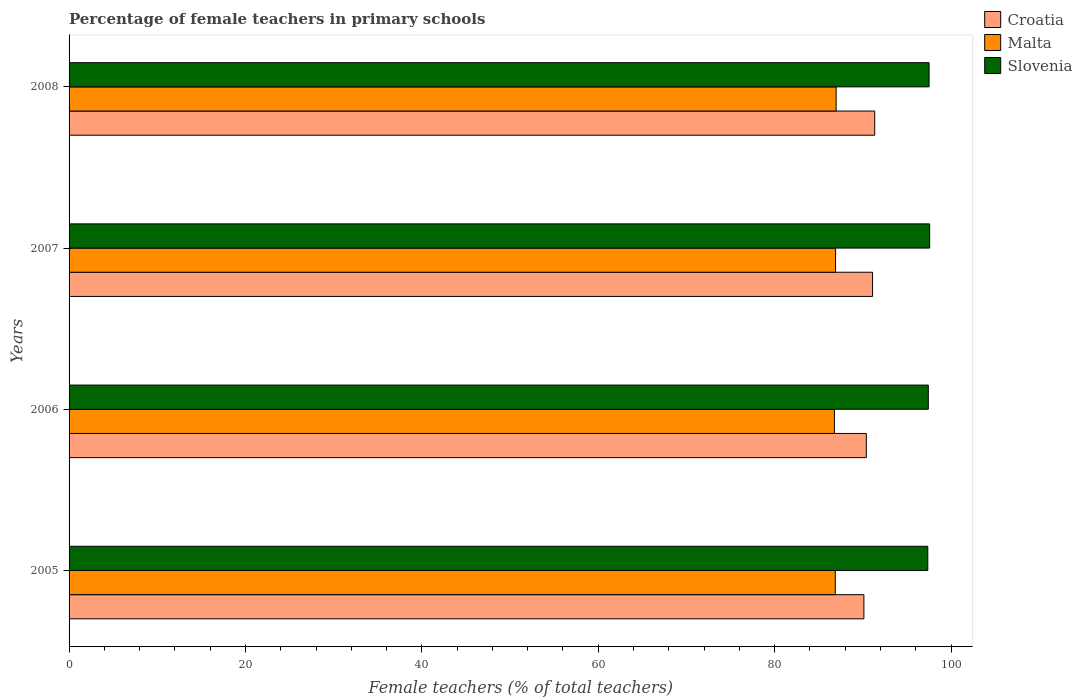How many groups of bars are there?
Keep it short and to the point. 4. Are the number of bars per tick equal to the number of legend labels?
Provide a short and direct response. Yes. In how many cases, is the number of bars for a given year not equal to the number of legend labels?
Make the answer very short. 0. What is the percentage of female teachers in Slovenia in 2008?
Ensure brevity in your answer.  97.51. Across all years, what is the maximum percentage of female teachers in Malta?
Provide a short and direct response. 86.98. Across all years, what is the minimum percentage of female teachers in Slovenia?
Your response must be concise. 97.37. In which year was the percentage of female teachers in Malta minimum?
Your answer should be very brief. 2006. What is the total percentage of female teachers in Slovenia in the graph?
Keep it short and to the point. 389.89. What is the difference between the percentage of female teachers in Malta in 2006 and that in 2007?
Provide a short and direct response. -0.13. What is the difference between the percentage of female teachers in Malta in 2005 and the percentage of female teachers in Slovenia in 2008?
Offer a terse response. -10.63. What is the average percentage of female teachers in Slovenia per year?
Provide a short and direct response. 97.47. In the year 2006, what is the difference between the percentage of female teachers in Slovenia and percentage of female teachers in Malta?
Make the answer very short. 10.65. What is the ratio of the percentage of female teachers in Slovenia in 2005 to that in 2006?
Ensure brevity in your answer.  1. Is the percentage of female teachers in Croatia in 2006 less than that in 2007?
Provide a succinct answer. Yes. What is the difference between the highest and the second highest percentage of female teachers in Croatia?
Your answer should be compact. 0.24. What is the difference between the highest and the lowest percentage of female teachers in Slovenia?
Your response must be concise. 0.21. What does the 3rd bar from the top in 2005 represents?
Provide a short and direct response. Croatia. What does the 2nd bar from the bottom in 2006 represents?
Offer a terse response. Malta. How many bars are there?
Ensure brevity in your answer.  12. Are all the bars in the graph horizontal?
Give a very brief answer. Yes. How many years are there in the graph?
Make the answer very short. 4. What is the difference between two consecutive major ticks on the X-axis?
Your answer should be very brief. 20. Are the values on the major ticks of X-axis written in scientific E-notation?
Your answer should be compact. No. Does the graph contain any zero values?
Your answer should be compact. No. Where does the legend appear in the graph?
Give a very brief answer. Top right. What is the title of the graph?
Your answer should be compact. Percentage of female teachers in primary schools. Does "Greece" appear as one of the legend labels in the graph?
Provide a succinct answer. No. What is the label or title of the X-axis?
Your answer should be very brief. Female teachers (% of total teachers). What is the label or title of the Y-axis?
Your response must be concise. Years. What is the Female teachers (% of total teachers) in Croatia in 2005?
Give a very brief answer. 90.12. What is the Female teachers (% of total teachers) in Malta in 2005?
Your response must be concise. 86.88. What is the Female teachers (% of total teachers) of Slovenia in 2005?
Your response must be concise. 97.37. What is the Female teachers (% of total teachers) of Croatia in 2006?
Ensure brevity in your answer.  90.4. What is the Female teachers (% of total teachers) of Malta in 2006?
Your answer should be compact. 86.78. What is the Female teachers (% of total teachers) of Slovenia in 2006?
Provide a short and direct response. 97.43. What is the Female teachers (% of total teachers) of Croatia in 2007?
Ensure brevity in your answer.  91.11. What is the Female teachers (% of total teachers) in Malta in 2007?
Your answer should be very brief. 86.91. What is the Female teachers (% of total teachers) of Slovenia in 2007?
Your answer should be very brief. 97.58. What is the Female teachers (% of total teachers) of Croatia in 2008?
Offer a terse response. 91.35. What is the Female teachers (% of total teachers) of Malta in 2008?
Give a very brief answer. 86.98. What is the Female teachers (% of total teachers) in Slovenia in 2008?
Give a very brief answer. 97.51. Across all years, what is the maximum Female teachers (% of total teachers) of Croatia?
Provide a succinct answer. 91.35. Across all years, what is the maximum Female teachers (% of total teachers) of Malta?
Your answer should be compact. 86.98. Across all years, what is the maximum Female teachers (% of total teachers) in Slovenia?
Give a very brief answer. 97.58. Across all years, what is the minimum Female teachers (% of total teachers) in Croatia?
Offer a very short reply. 90.12. Across all years, what is the minimum Female teachers (% of total teachers) of Malta?
Give a very brief answer. 86.78. Across all years, what is the minimum Female teachers (% of total teachers) of Slovenia?
Your answer should be compact. 97.37. What is the total Female teachers (% of total teachers) in Croatia in the graph?
Your answer should be very brief. 362.98. What is the total Female teachers (% of total teachers) of Malta in the graph?
Provide a short and direct response. 347.54. What is the total Female teachers (% of total teachers) of Slovenia in the graph?
Provide a short and direct response. 389.89. What is the difference between the Female teachers (% of total teachers) in Croatia in 2005 and that in 2006?
Your answer should be very brief. -0.28. What is the difference between the Female teachers (% of total teachers) in Malta in 2005 and that in 2006?
Offer a very short reply. 0.1. What is the difference between the Female teachers (% of total teachers) in Slovenia in 2005 and that in 2006?
Offer a very short reply. -0.06. What is the difference between the Female teachers (% of total teachers) of Croatia in 2005 and that in 2007?
Give a very brief answer. -0.98. What is the difference between the Female teachers (% of total teachers) in Malta in 2005 and that in 2007?
Offer a terse response. -0.03. What is the difference between the Female teachers (% of total teachers) in Slovenia in 2005 and that in 2007?
Your response must be concise. -0.21. What is the difference between the Female teachers (% of total teachers) in Croatia in 2005 and that in 2008?
Keep it short and to the point. -1.22. What is the difference between the Female teachers (% of total teachers) in Malta in 2005 and that in 2008?
Provide a short and direct response. -0.1. What is the difference between the Female teachers (% of total teachers) in Slovenia in 2005 and that in 2008?
Ensure brevity in your answer.  -0.14. What is the difference between the Female teachers (% of total teachers) of Croatia in 2006 and that in 2007?
Your answer should be very brief. -0.71. What is the difference between the Female teachers (% of total teachers) of Malta in 2006 and that in 2007?
Your response must be concise. -0.13. What is the difference between the Female teachers (% of total teachers) in Slovenia in 2006 and that in 2007?
Your response must be concise. -0.15. What is the difference between the Female teachers (% of total teachers) of Croatia in 2006 and that in 2008?
Provide a succinct answer. -0.95. What is the difference between the Female teachers (% of total teachers) in Malta in 2006 and that in 2008?
Keep it short and to the point. -0.2. What is the difference between the Female teachers (% of total teachers) in Slovenia in 2006 and that in 2008?
Keep it short and to the point. -0.09. What is the difference between the Female teachers (% of total teachers) of Croatia in 2007 and that in 2008?
Make the answer very short. -0.24. What is the difference between the Female teachers (% of total teachers) in Malta in 2007 and that in 2008?
Your response must be concise. -0.07. What is the difference between the Female teachers (% of total teachers) in Slovenia in 2007 and that in 2008?
Provide a succinct answer. 0.07. What is the difference between the Female teachers (% of total teachers) of Croatia in 2005 and the Female teachers (% of total teachers) of Malta in 2006?
Offer a terse response. 3.34. What is the difference between the Female teachers (% of total teachers) of Croatia in 2005 and the Female teachers (% of total teachers) of Slovenia in 2006?
Offer a terse response. -7.3. What is the difference between the Female teachers (% of total teachers) in Malta in 2005 and the Female teachers (% of total teachers) in Slovenia in 2006?
Keep it short and to the point. -10.55. What is the difference between the Female teachers (% of total teachers) of Croatia in 2005 and the Female teachers (% of total teachers) of Malta in 2007?
Your answer should be compact. 3.21. What is the difference between the Female teachers (% of total teachers) in Croatia in 2005 and the Female teachers (% of total teachers) in Slovenia in 2007?
Your response must be concise. -7.45. What is the difference between the Female teachers (% of total teachers) in Malta in 2005 and the Female teachers (% of total teachers) in Slovenia in 2007?
Your answer should be very brief. -10.7. What is the difference between the Female teachers (% of total teachers) of Croatia in 2005 and the Female teachers (% of total teachers) of Malta in 2008?
Ensure brevity in your answer.  3.15. What is the difference between the Female teachers (% of total teachers) of Croatia in 2005 and the Female teachers (% of total teachers) of Slovenia in 2008?
Make the answer very short. -7.39. What is the difference between the Female teachers (% of total teachers) in Malta in 2005 and the Female teachers (% of total teachers) in Slovenia in 2008?
Your answer should be compact. -10.63. What is the difference between the Female teachers (% of total teachers) in Croatia in 2006 and the Female teachers (% of total teachers) in Malta in 2007?
Keep it short and to the point. 3.49. What is the difference between the Female teachers (% of total teachers) in Croatia in 2006 and the Female teachers (% of total teachers) in Slovenia in 2007?
Give a very brief answer. -7.18. What is the difference between the Female teachers (% of total teachers) in Malta in 2006 and the Female teachers (% of total teachers) in Slovenia in 2007?
Your answer should be very brief. -10.8. What is the difference between the Female teachers (% of total teachers) in Croatia in 2006 and the Female teachers (% of total teachers) in Malta in 2008?
Your answer should be compact. 3.42. What is the difference between the Female teachers (% of total teachers) in Croatia in 2006 and the Female teachers (% of total teachers) in Slovenia in 2008?
Your response must be concise. -7.11. What is the difference between the Female teachers (% of total teachers) of Malta in 2006 and the Female teachers (% of total teachers) of Slovenia in 2008?
Provide a short and direct response. -10.73. What is the difference between the Female teachers (% of total teachers) in Croatia in 2007 and the Female teachers (% of total teachers) in Malta in 2008?
Give a very brief answer. 4.13. What is the difference between the Female teachers (% of total teachers) in Croatia in 2007 and the Female teachers (% of total teachers) in Slovenia in 2008?
Provide a succinct answer. -6.41. What is the difference between the Female teachers (% of total teachers) of Malta in 2007 and the Female teachers (% of total teachers) of Slovenia in 2008?
Offer a very short reply. -10.6. What is the average Female teachers (% of total teachers) of Croatia per year?
Provide a short and direct response. 90.74. What is the average Female teachers (% of total teachers) in Malta per year?
Keep it short and to the point. 86.89. What is the average Female teachers (% of total teachers) in Slovenia per year?
Give a very brief answer. 97.47. In the year 2005, what is the difference between the Female teachers (% of total teachers) of Croatia and Female teachers (% of total teachers) of Malta?
Keep it short and to the point. 3.25. In the year 2005, what is the difference between the Female teachers (% of total teachers) of Croatia and Female teachers (% of total teachers) of Slovenia?
Your response must be concise. -7.25. In the year 2005, what is the difference between the Female teachers (% of total teachers) of Malta and Female teachers (% of total teachers) of Slovenia?
Your answer should be very brief. -10.49. In the year 2006, what is the difference between the Female teachers (% of total teachers) of Croatia and Female teachers (% of total teachers) of Malta?
Provide a short and direct response. 3.62. In the year 2006, what is the difference between the Female teachers (% of total teachers) in Croatia and Female teachers (% of total teachers) in Slovenia?
Keep it short and to the point. -7.03. In the year 2006, what is the difference between the Female teachers (% of total teachers) in Malta and Female teachers (% of total teachers) in Slovenia?
Keep it short and to the point. -10.65. In the year 2007, what is the difference between the Female teachers (% of total teachers) in Croatia and Female teachers (% of total teachers) in Malta?
Offer a terse response. 4.2. In the year 2007, what is the difference between the Female teachers (% of total teachers) in Croatia and Female teachers (% of total teachers) in Slovenia?
Provide a short and direct response. -6.47. In the year 2007, what is the difference between the Female teachers (% of total teachers) in Malta and Female teachers (% of total teachers) in Slovenia?
Your answer should be very brief. -10.67. In the year 2008, what is the difference between the Female teachers (% of total teachers) of Croatia and Female teachers (% of total teachers) of Malta?
Give a very brief answer. 4.37. In the year 2008, what is the difference between the Female teachers (% of total teachers) in Croatia and Female teachers (% of total teachers) in Slovenia?
Provide a succinct answer. -6.17. In the year 2008, what is the difference between the Female teachers (% of total teachers) of Malta and Female teachers (% of total teachers) of Slovenia?
Offer a very short reply. -10.54. What is the ratio of the Female teachers (% of total teachers) in Malta in 2005 to that in 2006?
Ensure brevity in your answer.  1. What is the ratio of the Female teachers (% of total teachers) of Slovenia in 2005 to that in 2006?
Offer a terse response. 1. What is the ratio of the Female teachers (% of total teachers) in Croatia in 2005 to that in 2007?
Offer a terse response. 0.99. What is the ratio of the Female teachers (% of total teachers) of Slovenia in 2005 to that in 2007?
Your answer should be compact. 1. What is the ratio of the Female teachers (% of total teachers) of Croatia in 2005 to that in 2008?
Provide a short and direct response. 0.99. What is the ratio of the Female teachers (% of total teachers) of Slovenia in 2005 to that in 2008?
Your response must be concise. 1. What is the ratio of the Female teachers (% of total teachers) in Croatia in 2006 to that in 2007?
Offer a terse response. 0.99. What is the ratio of the Female teachers (% of total teachers) in Croatia in 2006 to that in 2008?
Make the answer very short. 0.99. What is the ratio of the Female teachers (% of total teachers) in Slovenia in 2006 to that in 2008?
Give a very brief answer. 1. What is the ratio of the Female teachers (% of total teachers) of Slovenia in 2007 to that in 2008?
Offer a very short reply. 1. What is the difference between the highest and the second highest Female teachers (% of total teachers) in Croatia?
Give a very brief answer. 0.24. What is the difference between the highest and the second highest Female teachers (% of total teachers) of Malta?
Offer a terse response. 0.07. What is the difference between the highest and the second highest Female teachers (% of total teachers) in Slovenia?
Ensure brevity in your answer.  0.07. What is the difference between the highest and the lowest Female teachers (% of total teachers) in Croatia?
Give a very brief answer. 1.22. What is the difference between the highest and the lowest Female teachers (% of total teachers) in Malta?
Your answer should be compact. 0.2. What is the difference between the highest and the lowest Female teachers (% of total teachers) of Slovenia?
Give a very brief answer. 0.21. 